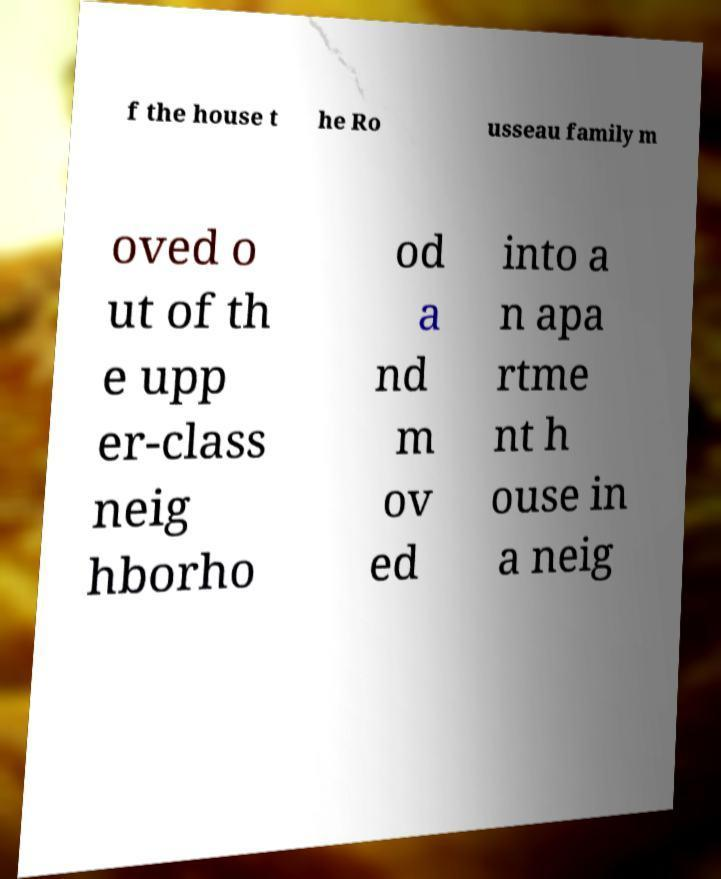There's text embedded in this image that I need extracted. Can you transcribe it verbatim? f the house t he Ro usseau family m oved o ut of th e upp er-class neig hborho od a nd m ov ed into a n apa rtme nt h ouse in a neig 